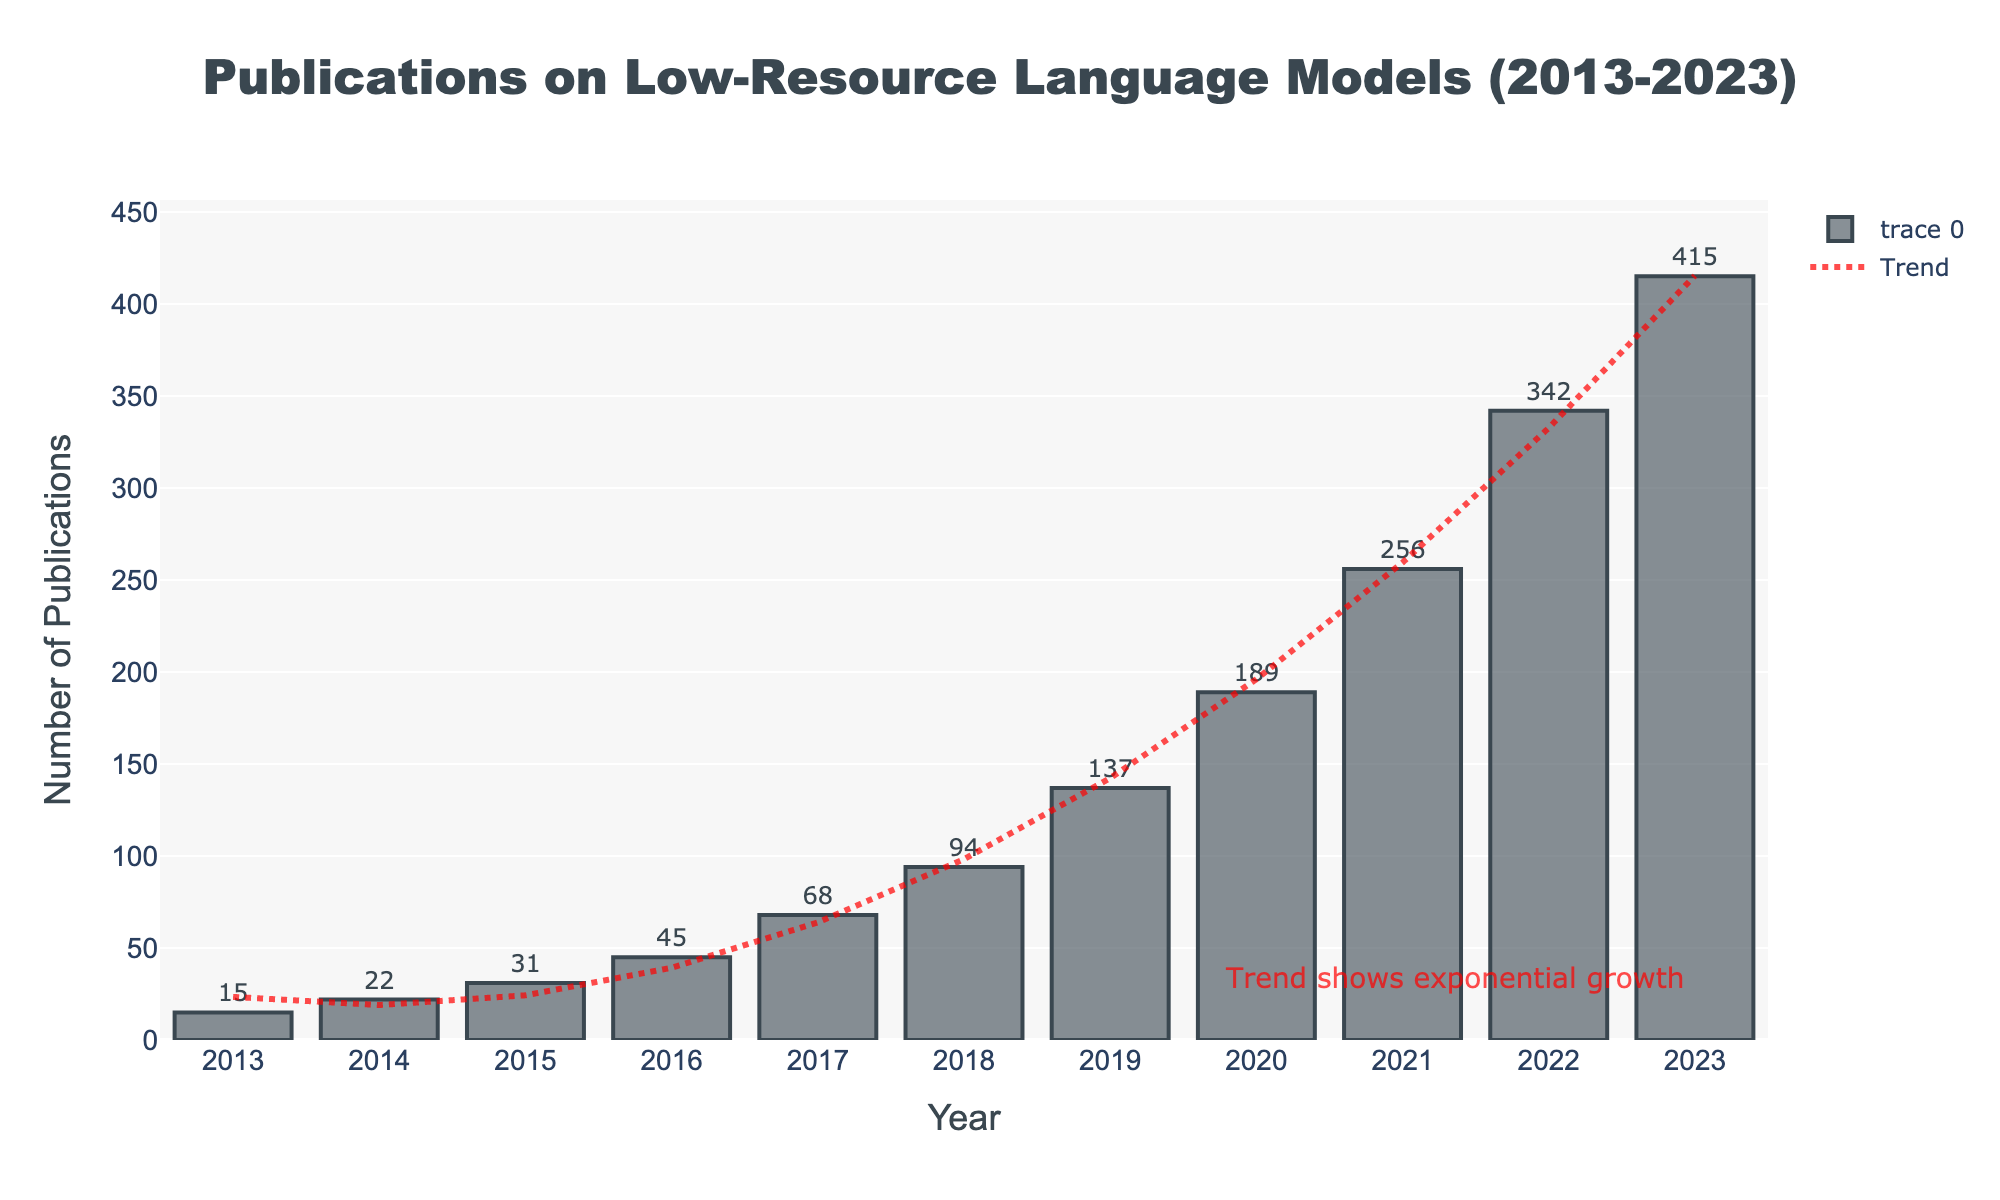What is the total number of publications from 2013 to 2015? Sum the publications from the years 2013 (15), 2014 (22), and 2015 (31). The total is 15 + 22 + 31 = 68.
Answer: 68 Which year had the highest increase in the number of publications compared to the previous year? Subtract the number of publications of each year from the previous year. The largest increase is from 2022 (342) to 2023 (415): 415 - 342 = 73.
Answer: 2023 What is the average number of publications per year from 2018 to 2020? Sum the publications for 2018 (94), 2019 (137), and 2020 (189), then divide by 3. The average is (94 + 137 + 189) / 3 = 420 / 3 = 140.
Answer: 140 How does the number of publications in 2017 compare to that in 2019? Compare the values for 2017 (68) and 2019 (137). Since 137 > 68, there is an increase.
Answer: 2019 had more What is the most distinctive feature of the visual representation of the trend? Observe that the trend line is represented as a red dashed line and shows an exponential growth pattern.
Answer: Exponential growth In which year did the publications exceed 100 for the first time? Identify the first year where the number of publications is greater than 100. This occurs in 2018 with 94 publications only reaching 137 in 2019.
Answer: 2019 What is the percentage growth in the number of publications from 2021 to 2022? Calculate the percentage growth using the formula: ((342 - 256) / 256) * 100. This results in (86 / 256) * 100 ≈ 33.59%.
Answer: 33.59% What is the color of the bars representing the publications? Look at the appearance of the bars in the chart, which are dark and slightly translucent. The exact color is a dark grey.
Answer: Dark grey 